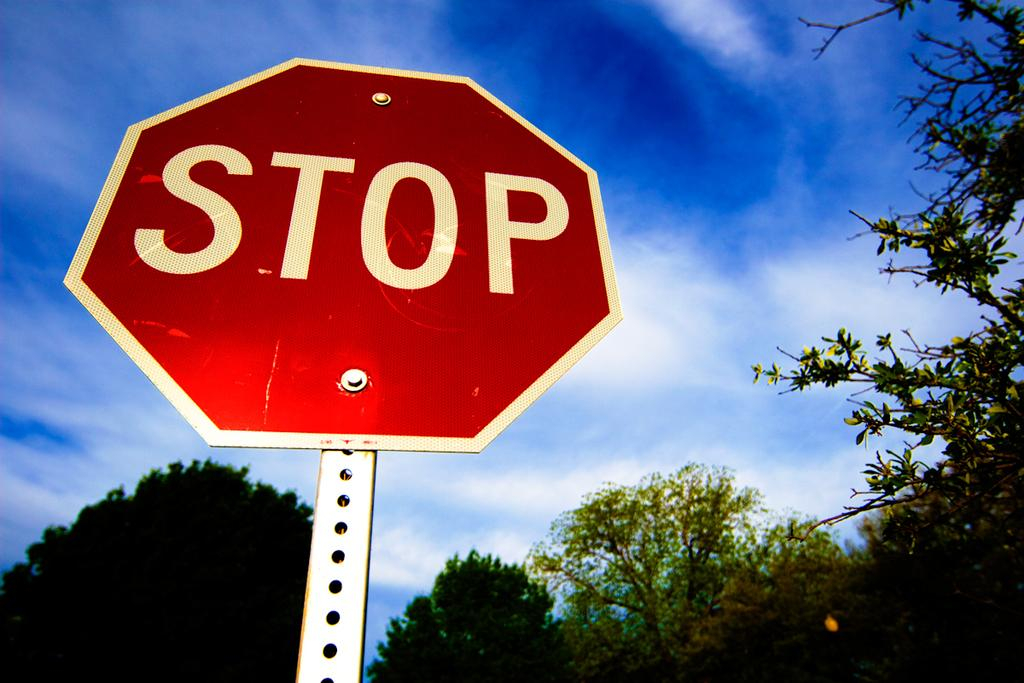<image>
Summarize the visual content of the image. Red octagon sign with STOP in white letters on a silver pole. 